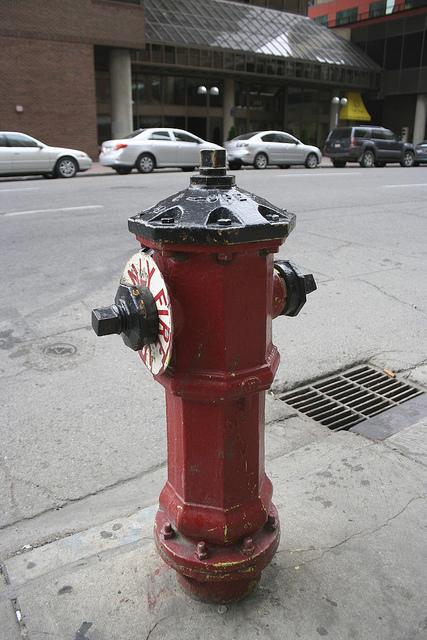What profession utilizes the red item in the foreground? Please explain your reasoning. fire fighter. Hydrants give water which fire fighters use. 